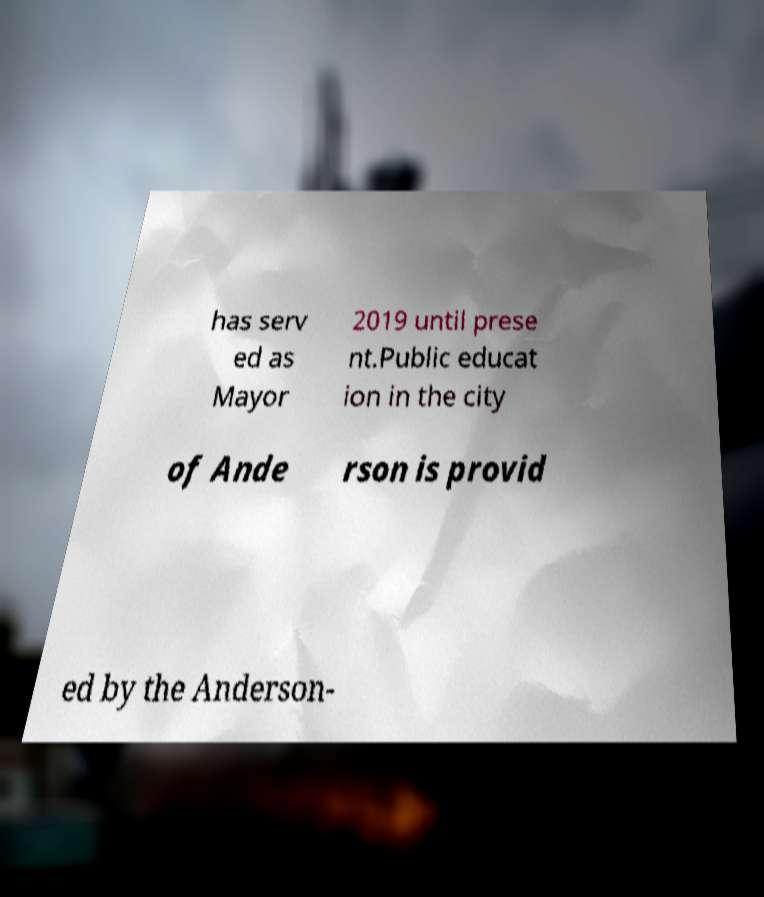Can you read and provide the text displayed in the image?This photo seems to have some interesting text. Can you extract and type it out for me? has serv ed as Mayor 2019 until prese nt.Public educat ion in the city of Ande rson is provid ed by the Anderson- 